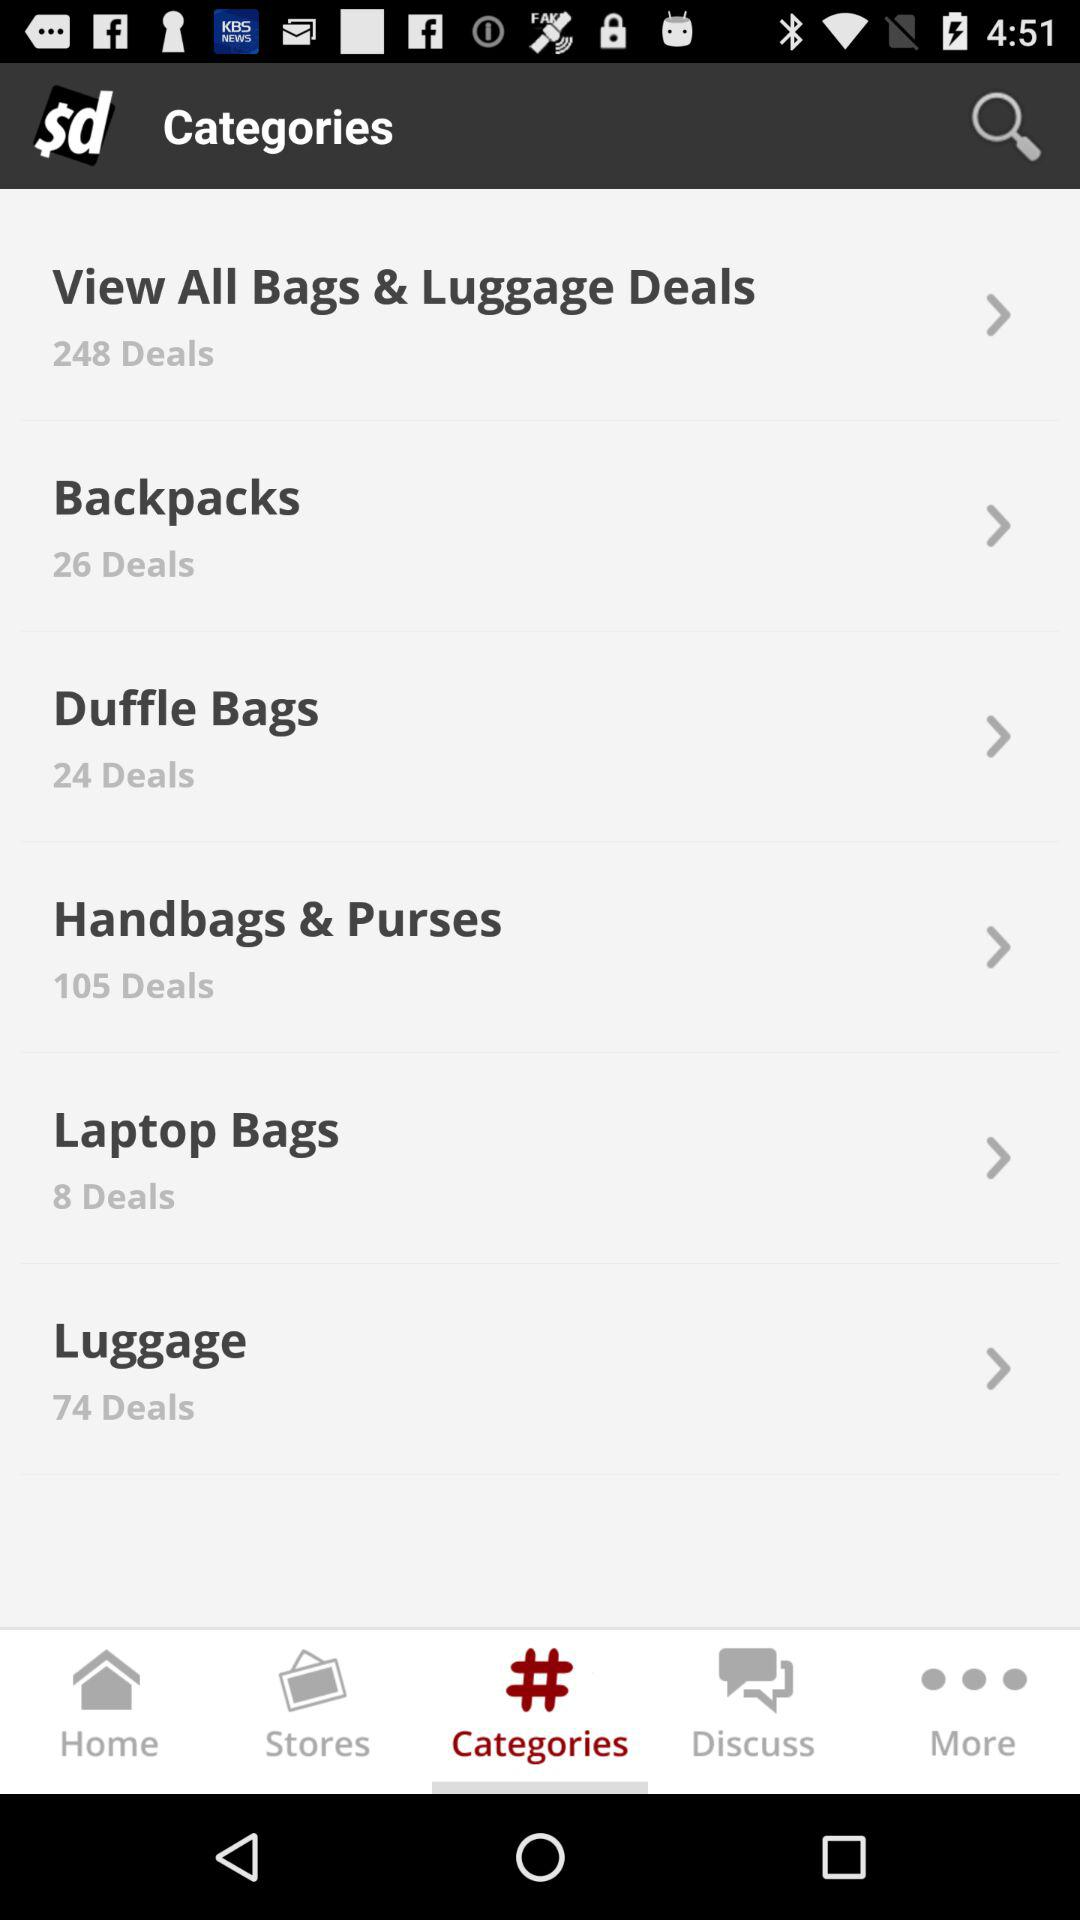How many more deals are there for backpacks than for laptop bags?
Answer the question using a single word or phrase. 18 